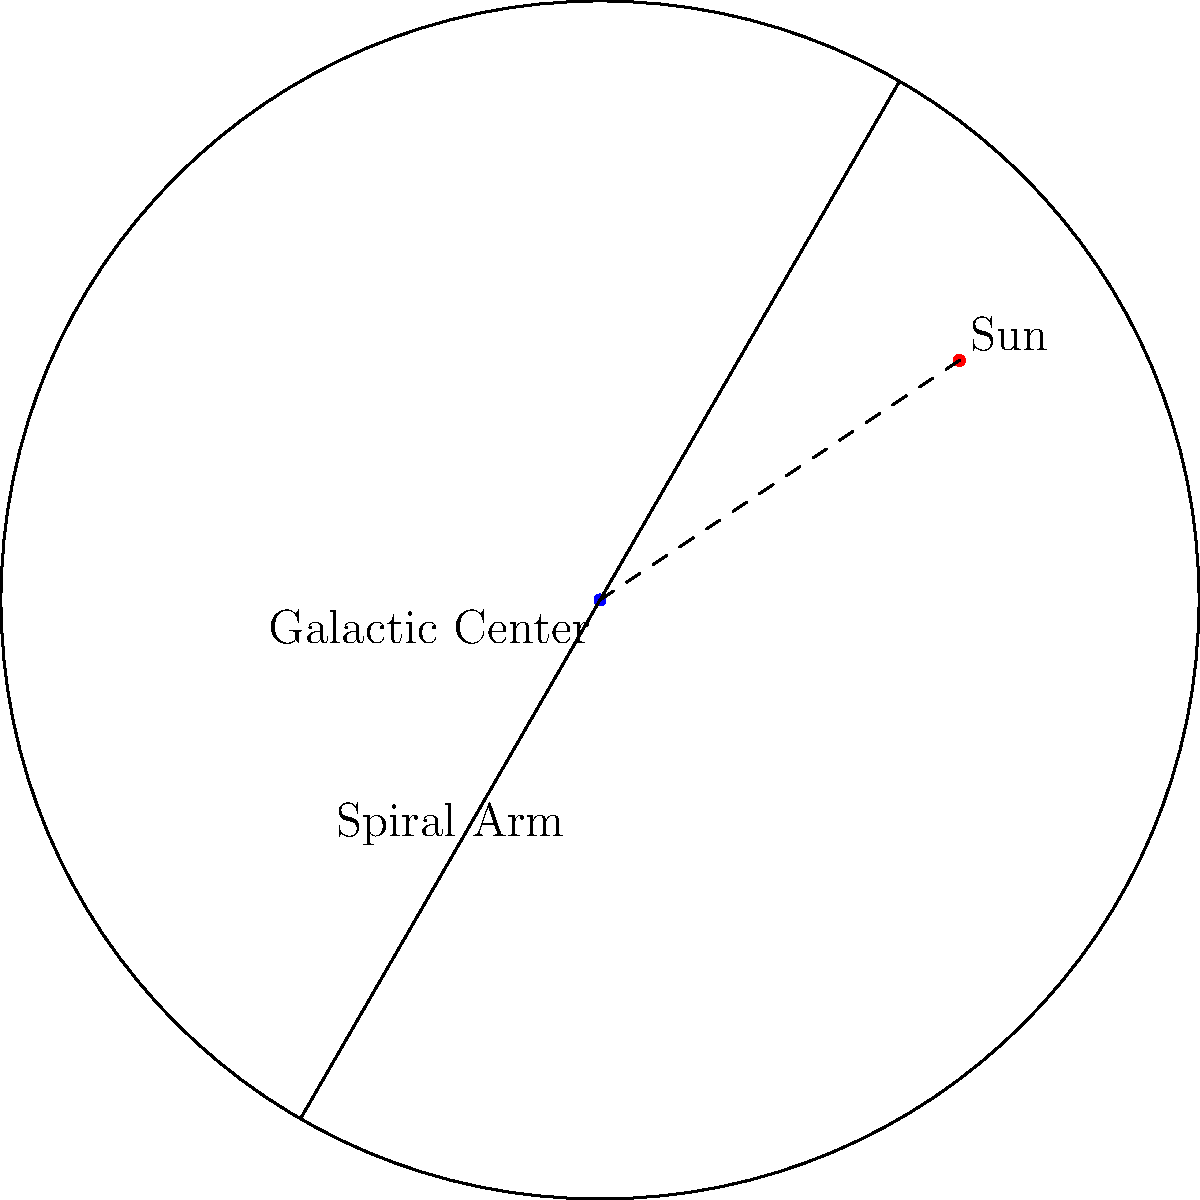In the diagram representing the Milky Way galaxy, the Sun's position is marked in red. Based on this, which statement best describes our location within the galaxy, and how might this affect our ability to observe distant parts of the galaxy? To answer this question, let's analyze the diagram step-by-step:

1. Galaxy structure: The diagram shows a top-down view of the Milky Way galaxy, represented as a circular disk.

2. Sun's position: The red dot indicates the Sun's location, which is:
   a) Not at the center of the galaxy
   b) Roughly 3/5 of the way from the center to the edge of the galactic disk

3. Galactic center: The blue dot at the center represents the galactic center, where the supermassive black hole Sagittarius A* is located.

4. Spiral arms: The two lines emanating from the center represent spiral arms, a key feature of our galaxy's structure.

5. Implications for observation:
   a) Being off-center allows us to observe the galactic center and the opposite side of the galaxy.
   b) However, our view of distant parts of the galaxy is obscured by the dense concentration of stars, gas, and dust in the galactic plane.

6. Distance estimation: The dashed line between the Sun and the galactic center represents a distance of approximately 26,000 light-years.

7. Observational challenges:
   a) Visible light from distant parts of the galaxy is often blocked by intervening matter.
   b) Radio and infrared observations are crucial for studying obscured regions.

Given this analysis, our location in the galaxy provides a unique vantage point for observing various galactic structures, but also presents challenges in observing distant regions due to obstruction by galactic material.
Answer: The Sun is located in the galactic disk, about 3/5 from the center to the edge, allowing observation of the galactic center but with some regions obscured by intervening matter. 